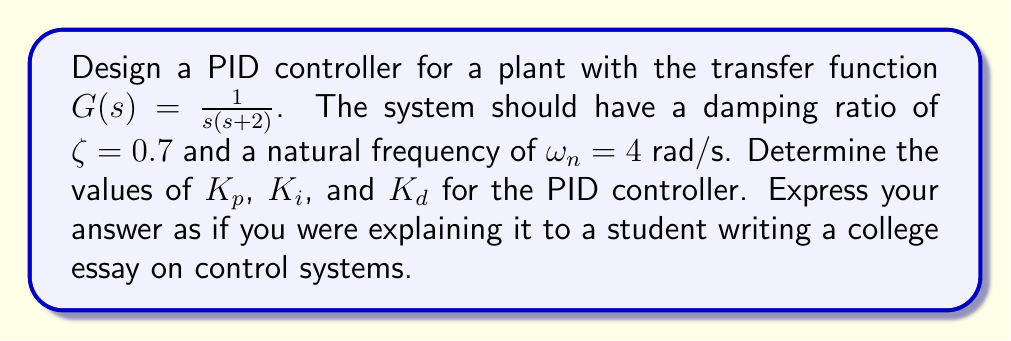Teach me how to tackle this problem. To design a PID controller for the given plant, we'll follow these steps:

1) The closed-loop transfer function of a system with PID control is:

   $$T(s) = \frac{G(s)C(s)}{1 + G(s)C(s)}$$

   where $C(s) = K_p + \frac{K_i}{s} + K_ds$ is the PID controller.

2) Substituting the given plant transfer function:

   $$T(s) = \frac{(K_p s + K_i + K_d s^2) / (s(s+2))}{1 + (K_p s + K_i + K_d s^2) / (s(s+2))}$$

3) Simplifying:

   $$T(s) = \frac{K_d s^2 + K_p s + K_i}{s^2 + (2+K_d)s + K_p s + K_i}$$

4) The characteristic equation of this system is:

   $$s^2 + (2+K_d)s + K_p s + K_i = 0$$

5) For the desired damping ratio and natural frequency, we want this to match the standard form:

   $$s^2 + 2\zeta\omega_n s + \omega_n^2 = 0$$

6) Equating coefficients:

   $2+K_d+K_p = 2\zeta\omega_n = 2(0.7)(4) = 5.6$
   $K_i = \omega_n^2 = 4^2 = 16$

7) We have some freedom in choosing $K_d$. Let's set $K_d = 1$ for simplicity. Then:

   $K_p = 5.6 - (2+K_d) = 5.6 - 3 = 2.6$
   $K_i = 16$
   $K_d = 1$

These values will give the desired damping ratio and natural frequency for the closed-loop system.
Answer: The PID controller parameters for the given plant to achieve a damping ratio of 0.7 and natural frequency of 4 rad/s are:

$K_p = 2.6$
$K_i = 16$
$K_d = 1$ 